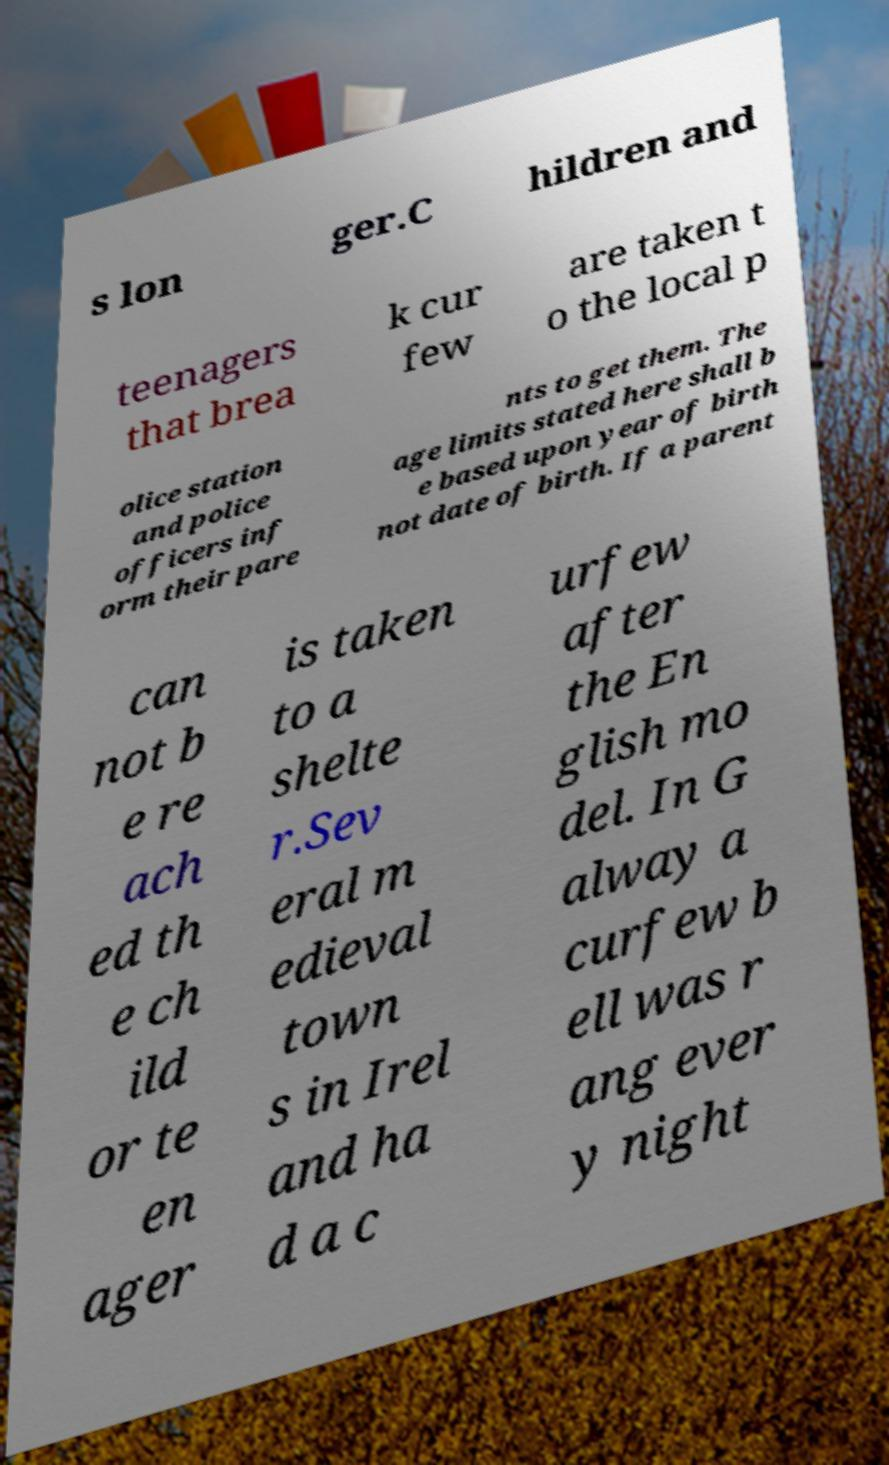Can you accurately transcribe the text from the provided image for me? s lon ger.C hildren and teenagers that brea k cur few are taken t o the local p olice station and police officers inf orm their pare nts to get them. The age limits stated here shall b e based upon year of birth not date of birth. If a parent can not b e re ach ed th e ch ild or te en ager is taken to a shelte r.Sev eral m edieval town s in Irel and ha d a c urfew after the En glish mo del. In G alway a curfew b ell was r ang ever y night 